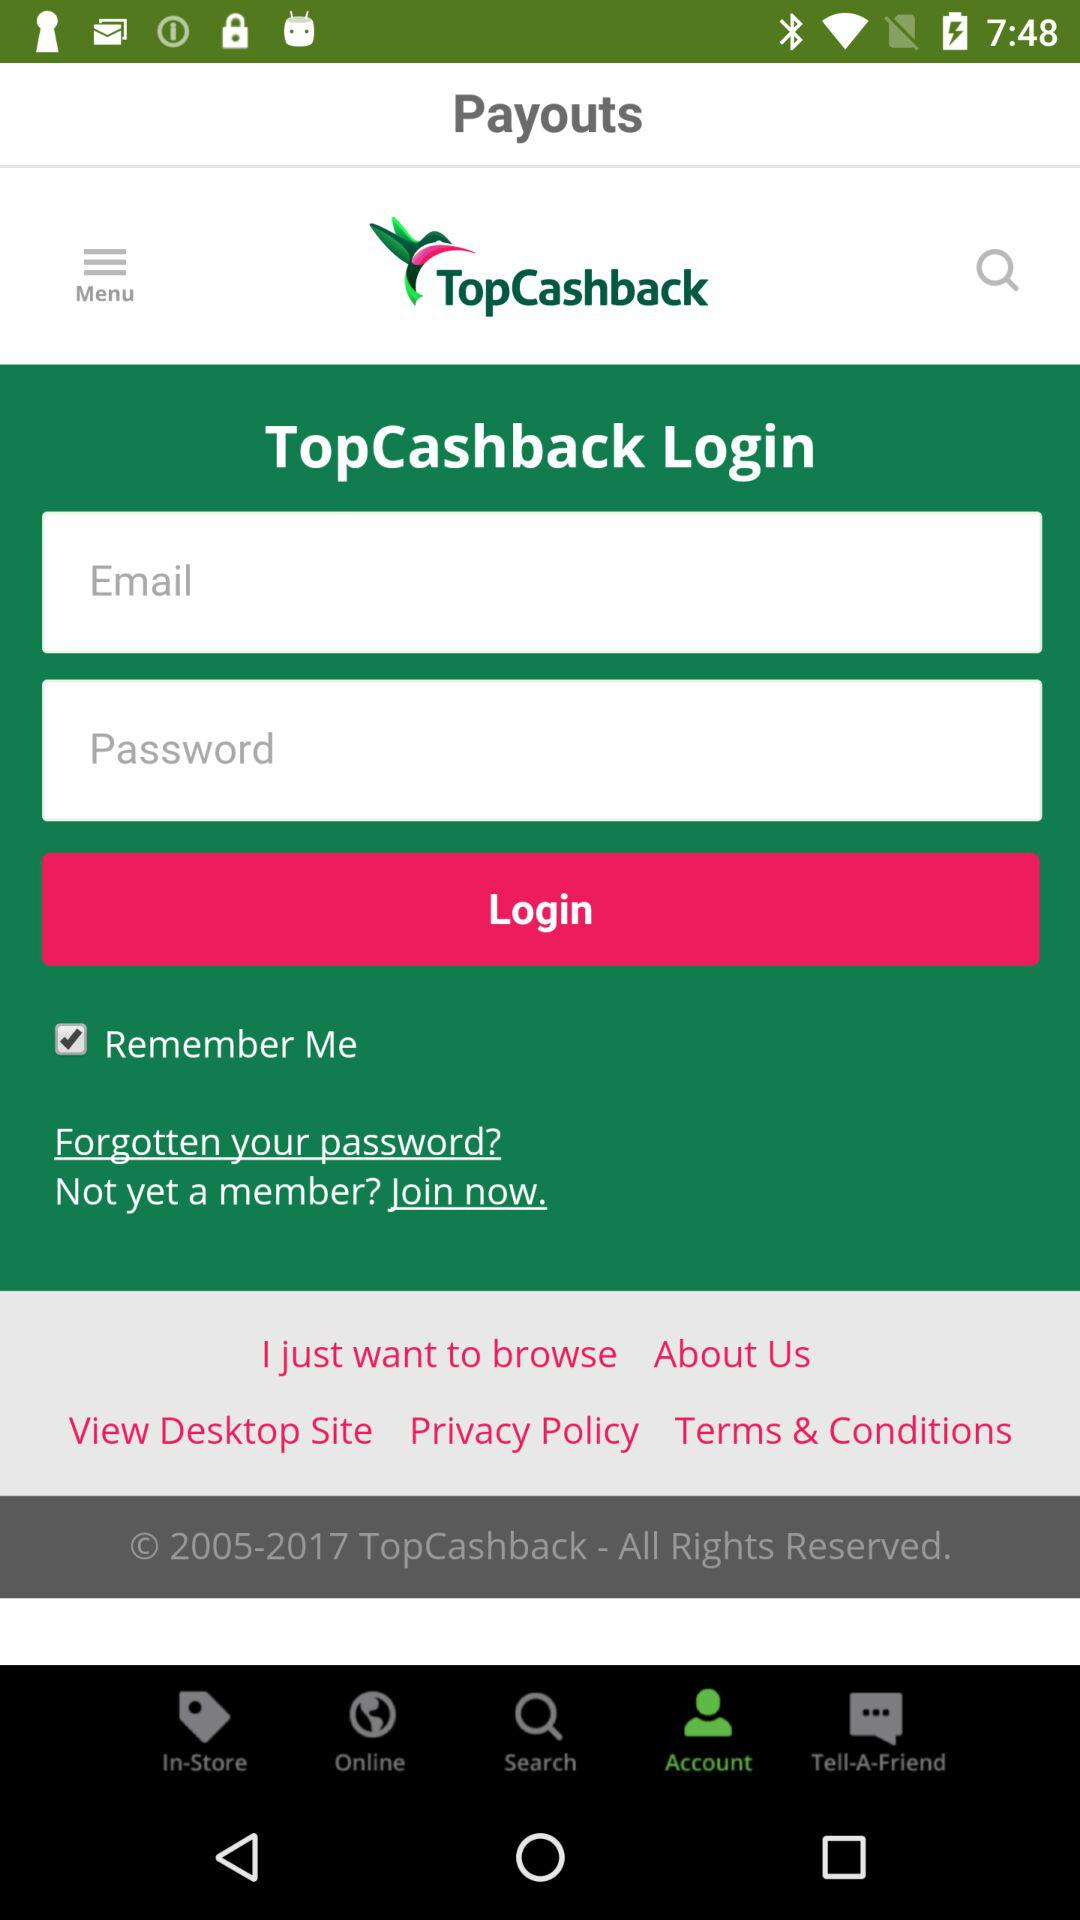What is the status of "Remember Me"? The status is "on". 